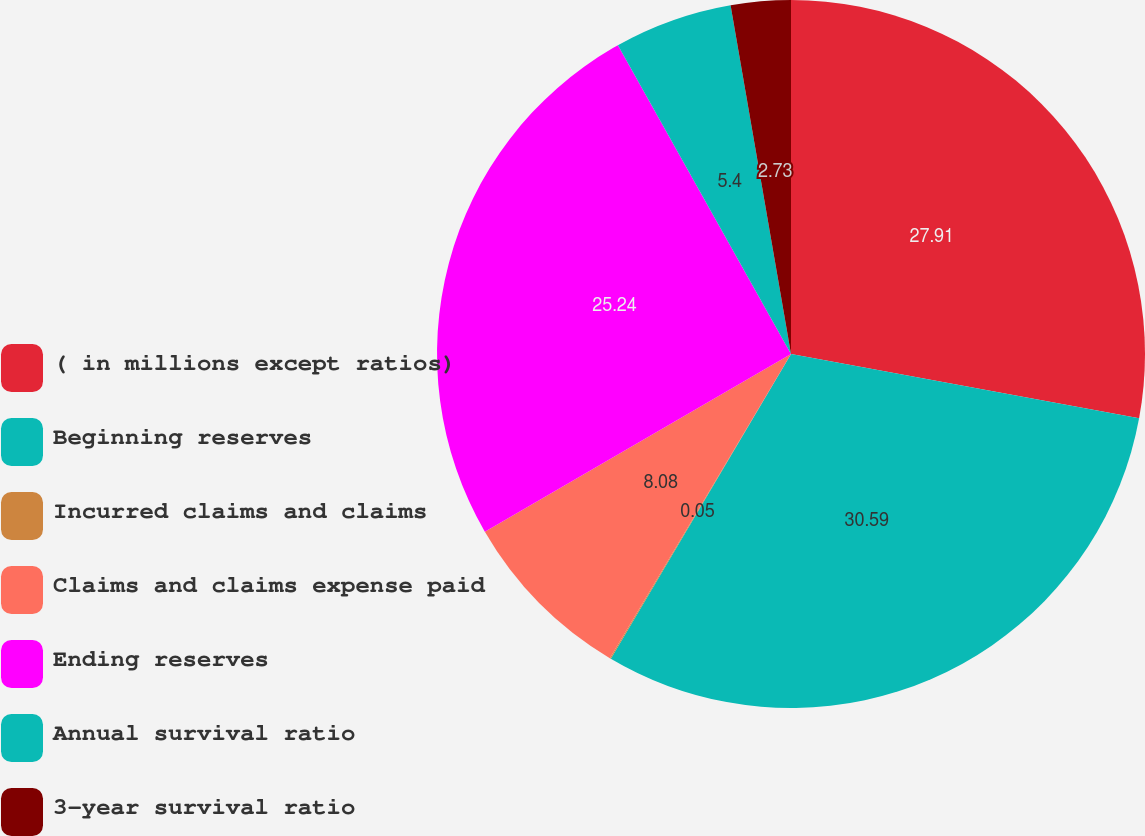Convert chart to OTSL. <chart><loc_0><loc_0><loc_500><loc_500><pie_chart><fcel>( in millions except ratios)<fcel>Beginning reserves<fcel>Incurred claims and claims<fcel>Claims and claims expense paid<fcel>Ending reserves<fcel>Annual survival ratio<fcel>3-year survival ratio<nl><fcel>27.91%<fcel>30.59%<fcel>0.05%<fcel>8.08%<fcel>25.24%<fcel>5.4%<fcel>2.73%<nl></chart> 